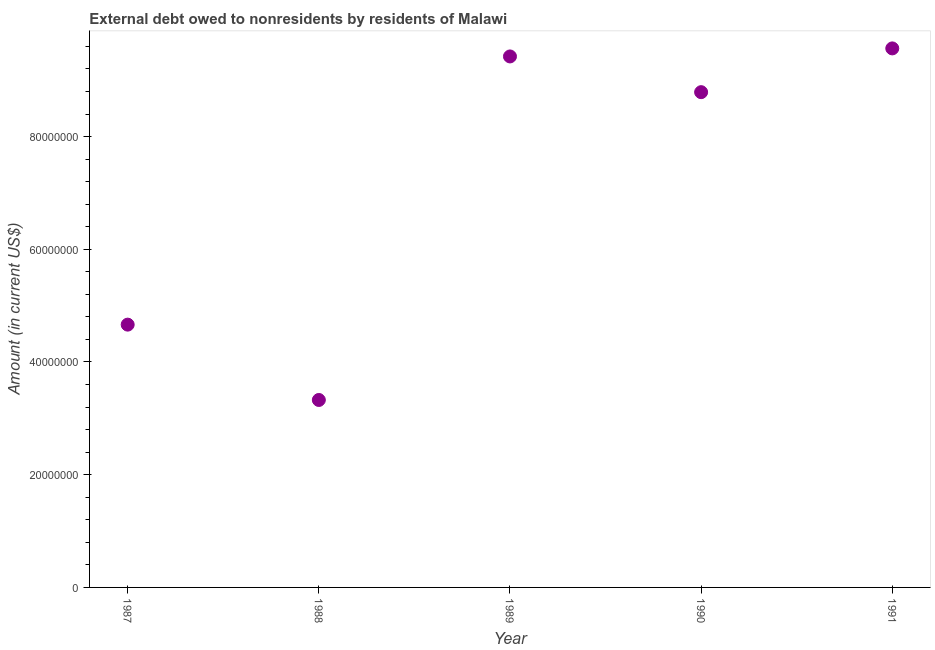What is the debt in 1988?
Your answer should be very brief. 3.33e+07. Across all years, what is the maximum debt?
Offer a very short reply. 9.56e+07. Across all years, what is the minimum debt?
Your answer should be very brief. 3.33e+07. In which year was the debt maximum?
Ensure brevity in your answer.  1991. In which year was the debt minimum?
Offer a terse response. 1988. What is the sum of the debt?
Offer a terse response. 3.58e+08. What is the difference between the debt in 1990 and 1991?
Offer a very short reply. -7.76e+06. What is the average debt per year?
Your answer should be very brief. 7.15e+07. What is the median debt?
Make the answer very short. 8.79e+07. What is the ratio of the debt in 1989 to that in 1991?
Provide a short and direct response. 0.99. Is the debt in 1988 less than that in 1989?
Your response must be concise. Yes. Is the difference between the debt in 1989 and 1991 greater than the difference between any two years?
Offer a very short reply. No. What is the difference between the highest and the second highest debt?
Your response must be concise. 1.43e+06. Is the sum of the debt in 1988 and 1989 greater than the maximum debt across all years?
Ensure brevity in your answer.  Yes. What is the difference between the highest and the lowest debt?
Your answer should be compact. 6.24e+07. Are the values on the major ticks of Y-axis written in scientific E-notation?
Offer a terse response. No. Does the graph contain grids?
Provide a succinct answer. No. What is the title of the graph?
Your response must be concise. External debt owed to nonresidents by residents of Malawi. What is the label or title of the X-axis?
Give a very brief answer. Year. What is the Amount (in current US$) in 1987?
Offer a very short reply. 4.66e+07. What is the Amount (in current US$) in 1988?
Ensure brevity in your answer.  3.33e+07. What is the Amount (in current US$) in 1989?
Make the answer very short. 9.42e+07. What is the Amount (in current US$) in 1990?
Offer a very short reply. 8.79e+07. What is the Amount (in current US$) in 1991?
Offer a terse response. 9.56e+07. What is the difference between the Amount (in current US$) in 1987 and 1988?
Keep it short and to the point. 1.34e+07. What is the difference between the Amount (in current US$) in 1987 and 1989?
Provide a succinct answer. -4.76e+07. What is the difference between the Amount (in current US$) in 1987 and 1990?
Offer a terse response. -4.12e+07. What is the difference between the Amount (in current US$) in 1987 and 1991?
Provide a short and direct response. -4.90e+07. What is the difference between the Amount (in current US$) in 1988 and 1989?
Your answer should be very brief. -6.10e+07. What is the difference between the Amount (in current US$) in 1988 and 1990?
Your answer should be very brief. -5.46e+07. What is the difference between the Amount (in current US$) in 1988 and 1991?
Your answer should be very brief. -6.24e+07. What is the difference between the Amount (in current US$) in 1989 and 1990?
Make the answer very short. 6.34e+06. What is the difference between the Amount (in current US$) in 1989 and 1991?
Ensure brevity in your answer.  -1.43e+06. What is the difference between the Amount (in current US$) in 1990 and 1991?
Give a very brief answer. -7.76e+06. What is the ratio of the Amount (in current US$) in 1987 to that in 1988?
Provide a short and direct response. 1.4. What is the ratio of the Amount (in current US$) in 1987 to that in 1989?
Make the answer very short. 0.49. What is the ratio of the Amount (in current US$) in 1987 to that in 1990?
Your answer should be compact. 0.53. What is the ratio of the Amount (in current US$) in 1987 to that in 1991?
Your answer should be compact. 0.49. What is the ratio of the Amount (in current US$) in 1988 to that in 1989?
Provide a succinct answer. 0.35. What is the ratio of the Amount (in current US$) in 1988 to that in 1990?
Offer a terse response. 0.38. What is the ratio of the Amount (in current US$) in 1988 to that in 1991?
Make the answer very short. 0.35. What is the ratio of the Amount (in current US$) in 1989 to that in 1990?
Your response must be concise. 1.07. What is the ratio of the Amount (in current US$) in 1990 to that in 1991?
Offer a terse response. 0.92. 